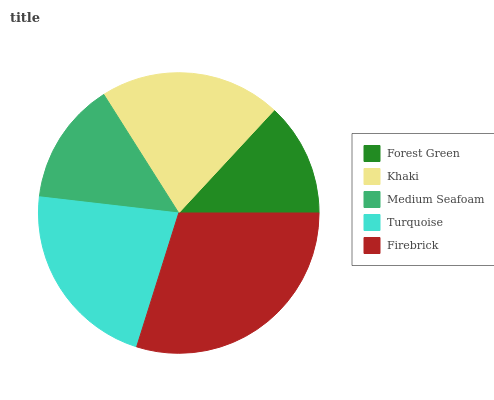Is Forest Green the minimum?
Answer yes or no. Yes. Is Firebrick the maximum?
Answer yes or no. Yes. Is Khaki the minimum?
Answer yes or no. No. Is Khaki the maximum?
Answer yes or no. No. Is Khaki greater than Forest Green?
Answer yes or no. Yes. Is Forest Green less than Khaki?
Answer yes or no. Yes. Is Forest Green greater than Khaki?
Answer yes or no. No. Is Khaki less than Forest Green?
Answer yes or no. No. Is Khaki the high median?
Answer yes or no. Yes. Is Khaki the low median?
Answer yes or no. Yes. Is Forest Green the high median?
Answer yes or no. No. Is Forest Green the low median?
Answer yes or no. No. 